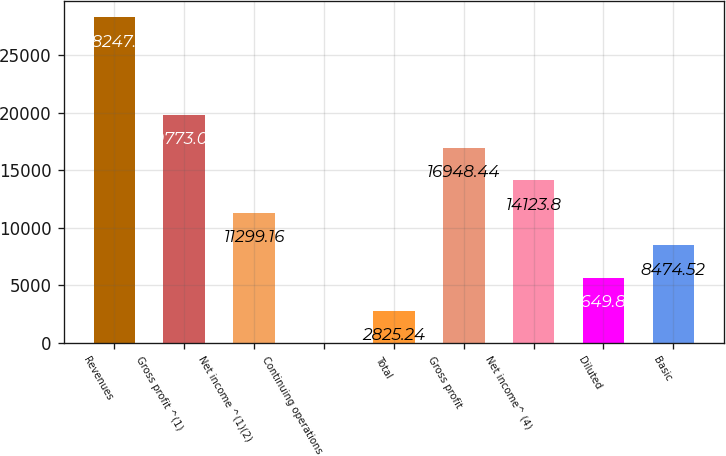Convert chart to OTSL. <chart><loc_0><loc_0><loc_500><loc_500><bar_chart><fcel>Revenues<fcel>Gross profit ^(1)<fcel>Net income ^(1)(2)<fcel>Continuing operations<fcel>Total<fcel>Gross profit<fcel>Net income^ (4)<fcel>Diluted<fcel>Basic<nl><fcel>28247<fcel>19773.1<fcel>11299.2<fcel>0.6<fcel>2825.24<fcel>16948.4<fcel>14123.8<fcel>5649.88<fcel>8474.52<nl></chart> 